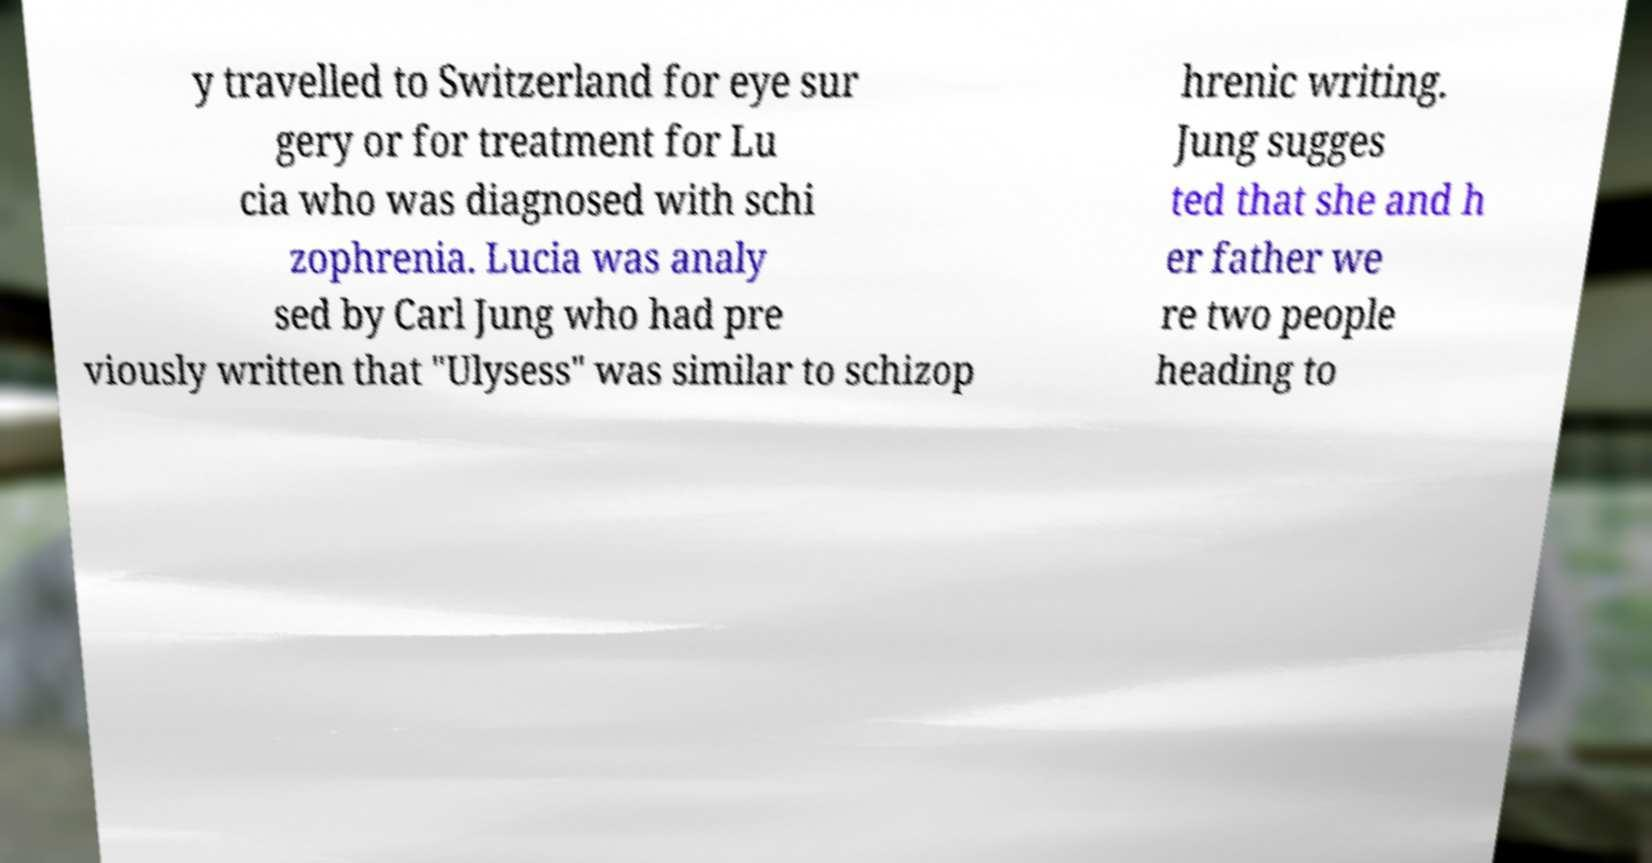Please read and relay the text visible in this image. What does it say? y travelled to Switzerland for eye sur gery or for treatment for Lu cia who was diagnosed with schi zophrenia. Lucia was analy sed by Carl Jung who had pre viously written that "Ulysess" was similar to schizop hrenic writing. Jung sugges ted that she and h er father we re two people heading to 